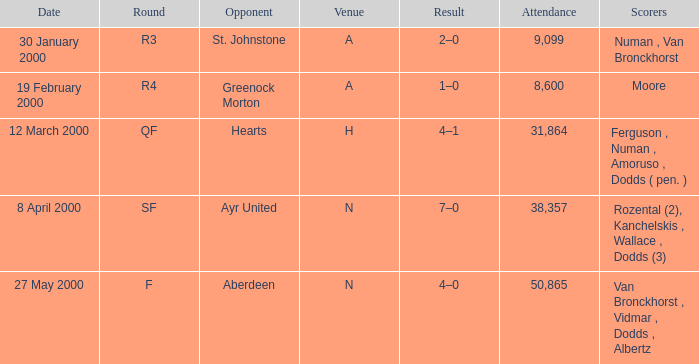Who was in a with opponent St. Johnstone? Numan , Van Bronckhorst. 